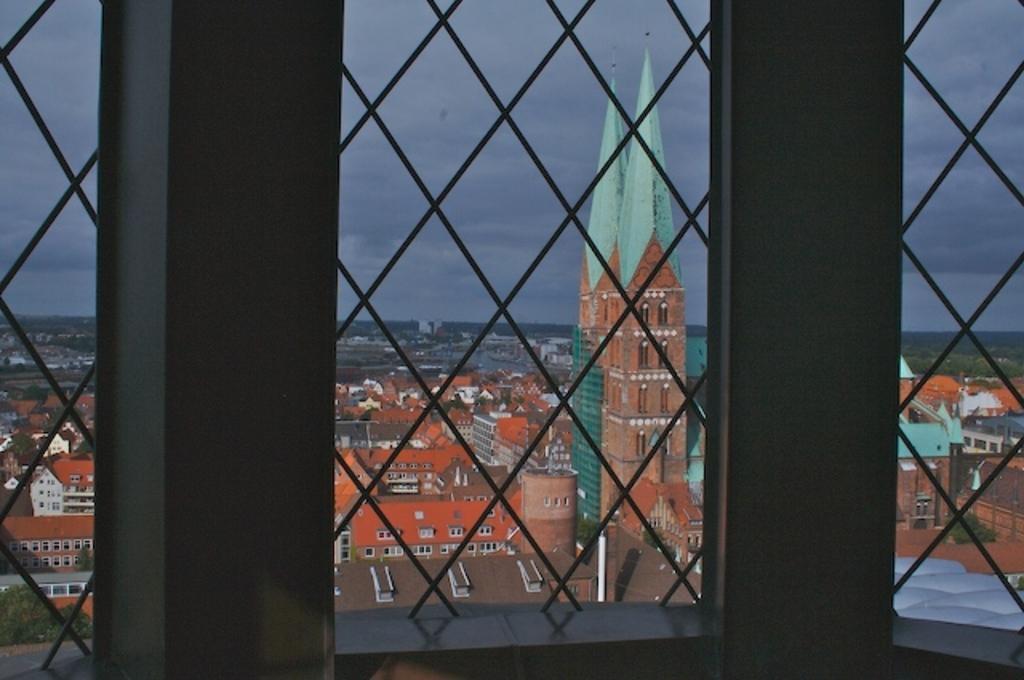How would you summarize this image in a sentence or two? In this image there are windows with grills in which we can see buildings, trees and sky. 